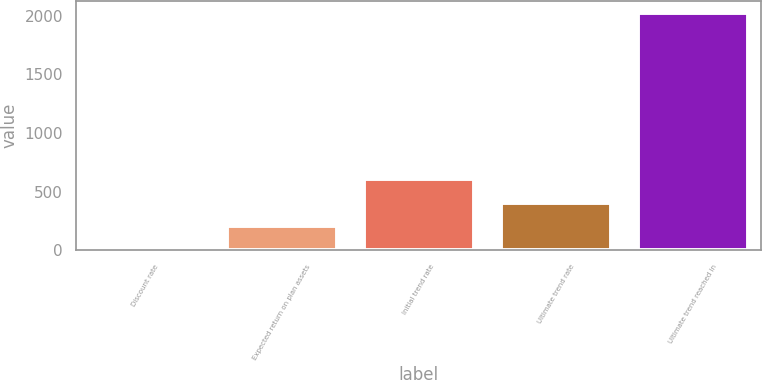Convert chart to OTSL. <chart><loc_0><loc_0><loc_500><loc_500><bar_chart><fcel>Discount rate<fcel>Expected return on plan assets<fcel>Initial trend rate<fcel>Ultimate trend rate<fcel>Ultimate trend reached in<nl><fcel>3.73<fcel>205.56<fcel>609.22<fcel>407.39<fcel>2022<nl></chart> 